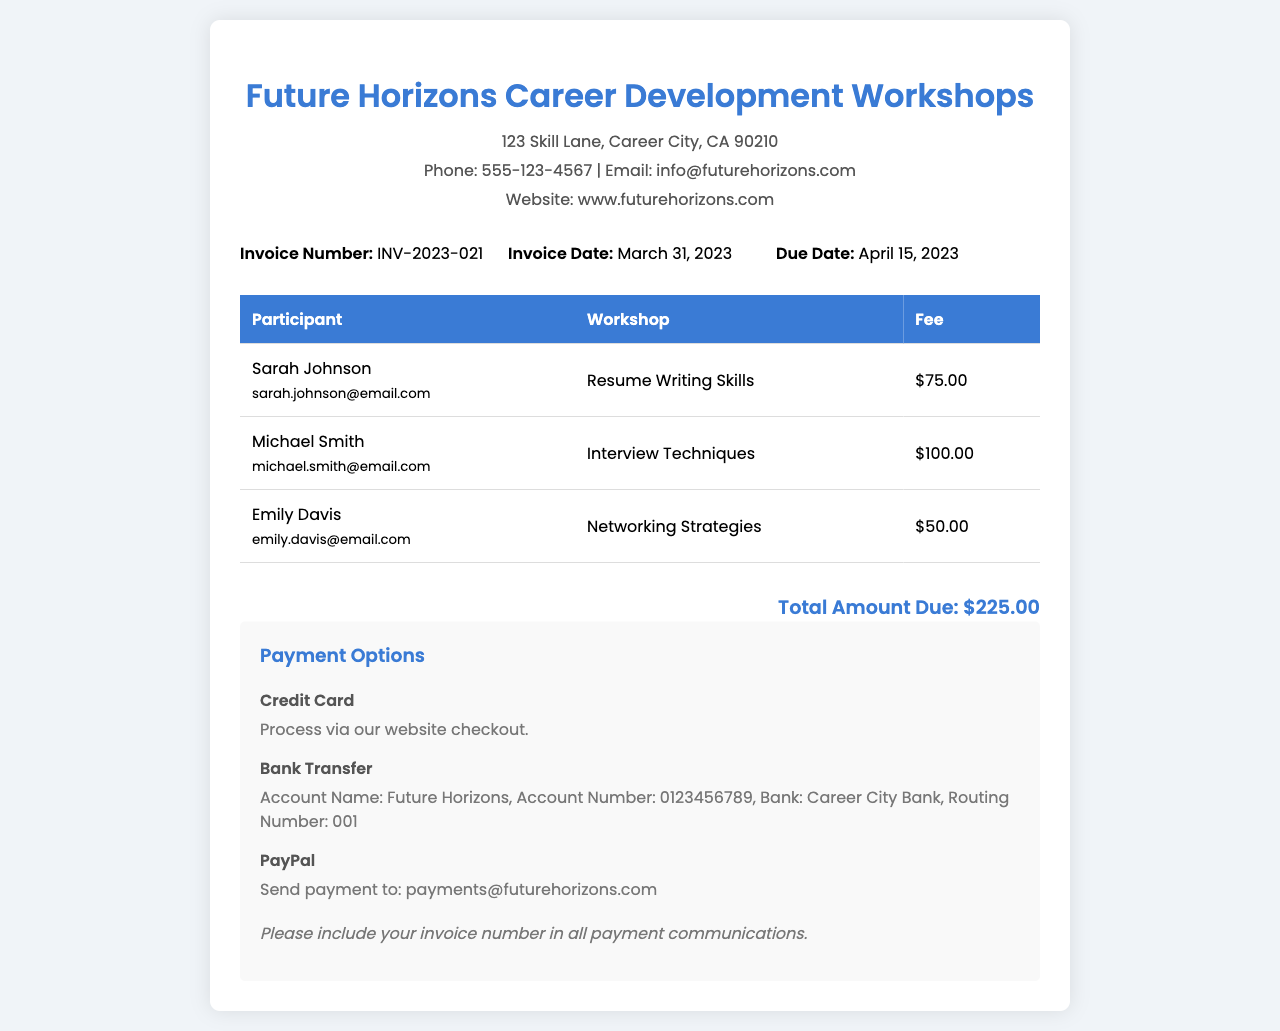What is the invoice number? The invoice number is provided at the top of the document, listing it distinctly from other information.
Answer: INV-2023-021 What is the total amount due? The total amount due is calculated from the fees of all participants listed in the table, found in the invoice.
Answer: $225.00 Who is the participant for the "Interview Techniques" workshop? The participant's name is associated with a specific workshop in the table section of the invoice.
Answer: Michael Smith When is the due date for this invoice? The due date is clearly stated within the invoice details section, indicating when the payment should be made.
Answer: April 15, 2023 What payment option requires an email send? The payment option involving sending an email is discussed in the payment options section of the document.
Answer: PayPal What is the fee for the "Networking Strategies" workshop? The fee is explicitly listed in the table alongside the participant's name and workshop title.
Answer: $50.00 What bank is associated with the bank transfer option? The bank's name for the transfer is specified in the payment options section.
Answer: Career City Bank How many participants are listed in the invoice? The number of participants can be counted from the table in the document showing details for each one.
Answer: 3 Which workshop costs the most? The cost of each workshop is compared in the fee column to determine which is the highest.
Answer: Interview Techniques 